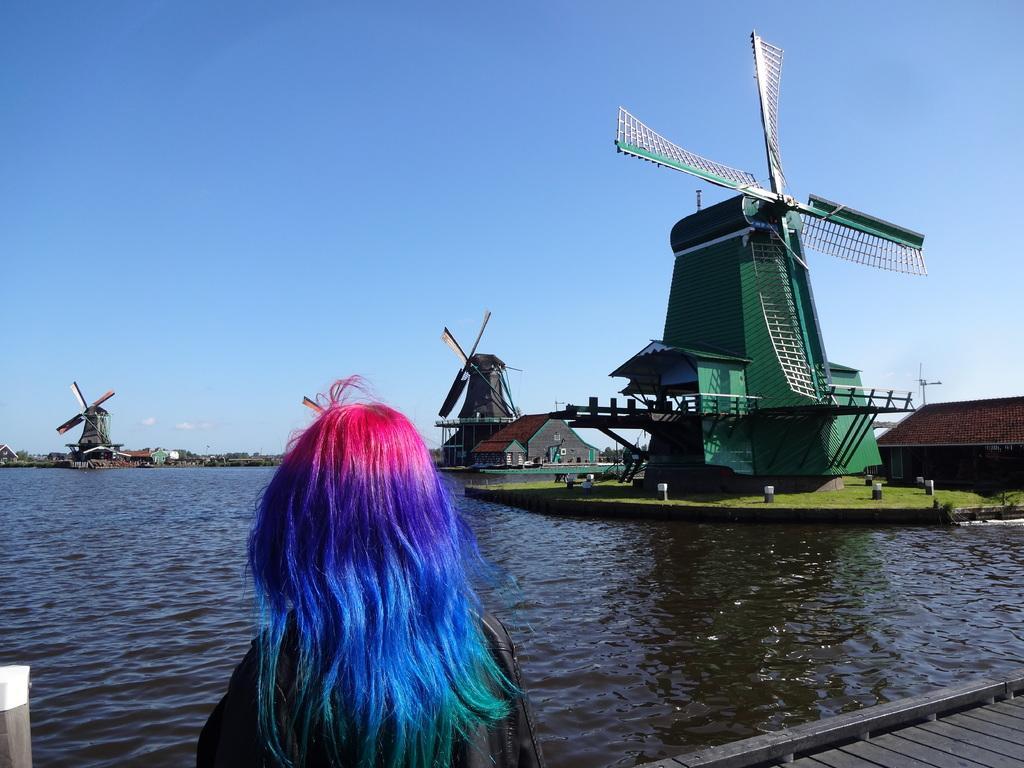Describe this image in one or two sentences. In the center of the image we can see a lady standing. In the background there are windmills and sheds. At the bottom there is water. In the background there is sky. 